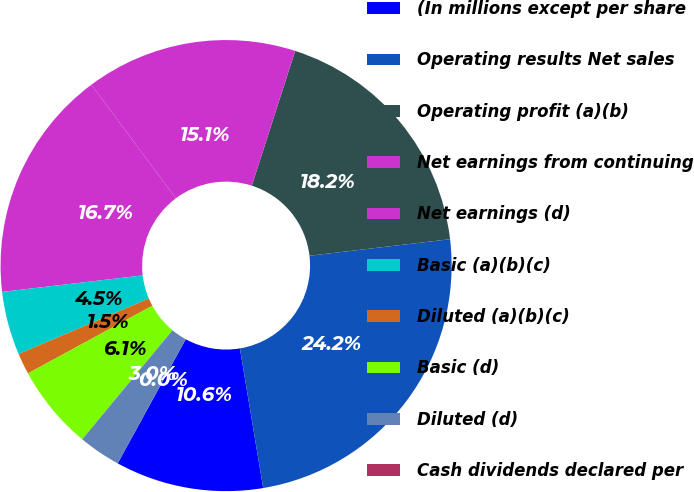<chart> <loc_0><loc_0><loc_500><loc_500><pie_chart><fcel>(In millions except per share<fcel>Operating results Net sales<fcel>Operating profit (a)(b)<fcel>Net earnings from continuing<fcel>Net earnings (d)<fcel>Basic (a)(b)(c)<fcel>Diluted (a)(b)(c)<fcel>Basic (d)<fcel>Diluted (d)<fcel>Cash dividends declared per<nl><fcel>10.61%<fcel>24.24%<fcel>18.18%<fcel>15.15%<fcel>16.67%<fcel>4.55%<fcel>1.52%<fcel>6.06%<fcel>3.03%<fcel>0.0%<nl></chart> 